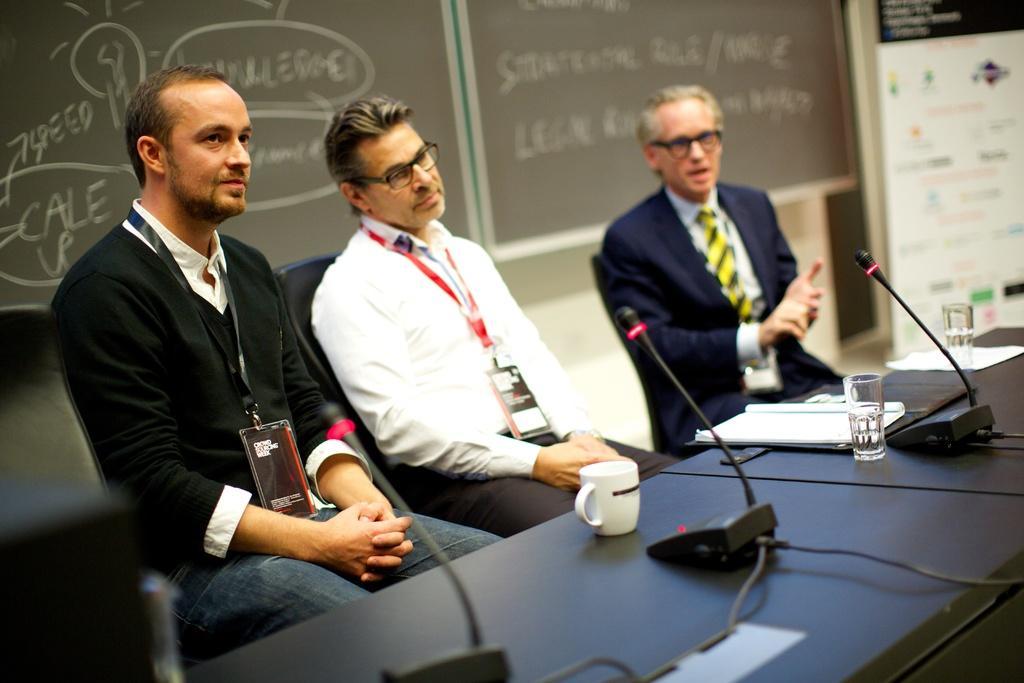Can you describe this image briefly? There are three persons sitting on the chairs as we can see in the middle of this image. There is a table at the bottom of this image. There are some Mics, a coffee cup,glass and some papers are kept on this table. There is a board in the background. 